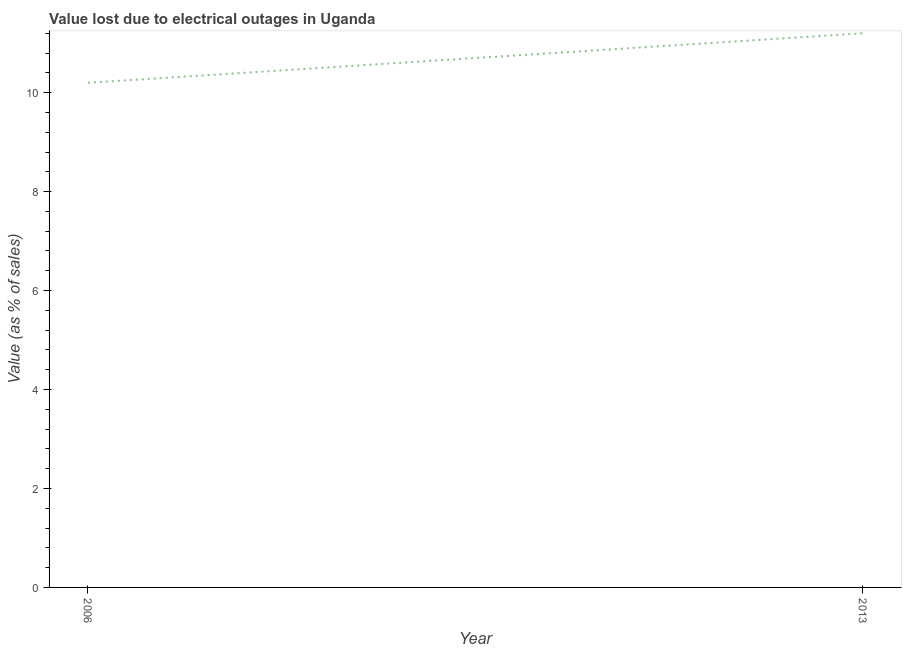What is the value lost due to electrical outages in 2006?
Keep it short and to the point. 10.2. In which year was the value lost due to electrical outages minimum?
Make the answer very short. 2006. What is the sum of the value lost due to electrical outages?
Give a very brief answer. 21.4. In how many years, is the value lost due to electrical outages greater than 8 %?
Ensure brevity in your answer.  2. Do a majority of the years between 2013 and 2006 (inclusive) have value lost due to electrical outages greater than 8.4 %?
Offer a very short reply. No. What is the ratio of the value lost due to electrical outages in 2006 to that in 2013?
Offer a terse response. 0.91. Is the value lost due to electrical outages in 2006 less than that in 2013?
Your response must be concise. Yes. How many lines are there?
Give a very brief answer. 1. How many years are there in the graph?
Provide a succinct answer. 2. Does the graph contain grids?
Your answer should be very brief. No. What is the title of the graph?
Your response must be concise. Value lost due to electrical outages in Uganda. What is the label or title of the X-axis?
Offer a very short reply. Year. What is the label or title of the Y-axis?
Your answer should be very brief. Value (as % of sales). What is the ratio of the Value (as % of sales) in 2006 to that in 2013?
Provide a succinct answer. 0.91. 